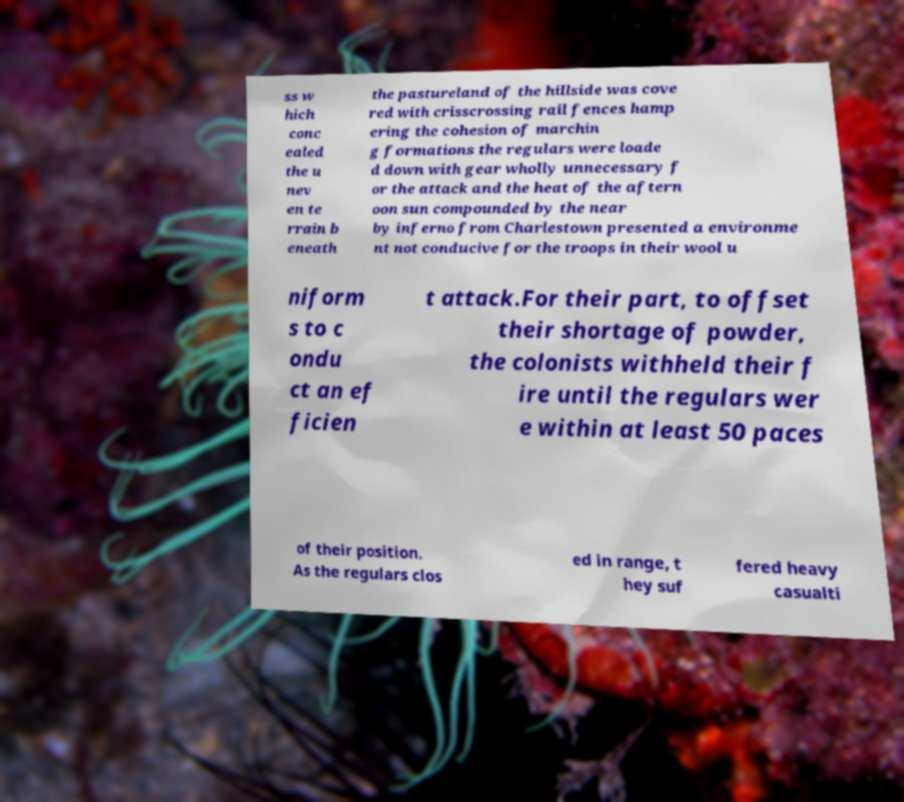Can you accurately transcribe the text from the provided image for me? ss w hich conc ealed the u nev en te rrain b eneath the pastureland of the hillside was cove red with crisscrossing rail fences hamp ering the cohesion of marchin g formations the regulars were loade d down with gear wholly unnecessary f or the attack and the heat of the aftern oon sun compounded by the near by inferno from Charlestown presented a environme nt not conducive for the troops in their wool u niform s to c ondu ct an ef ficien t attack.For their part, to offset their shortage of powder, the colonists withheld their f ire until the regulars wer e within at least 50 paces of their position. As the regulars clos ed in range, t hey suf fered heavy casualti 